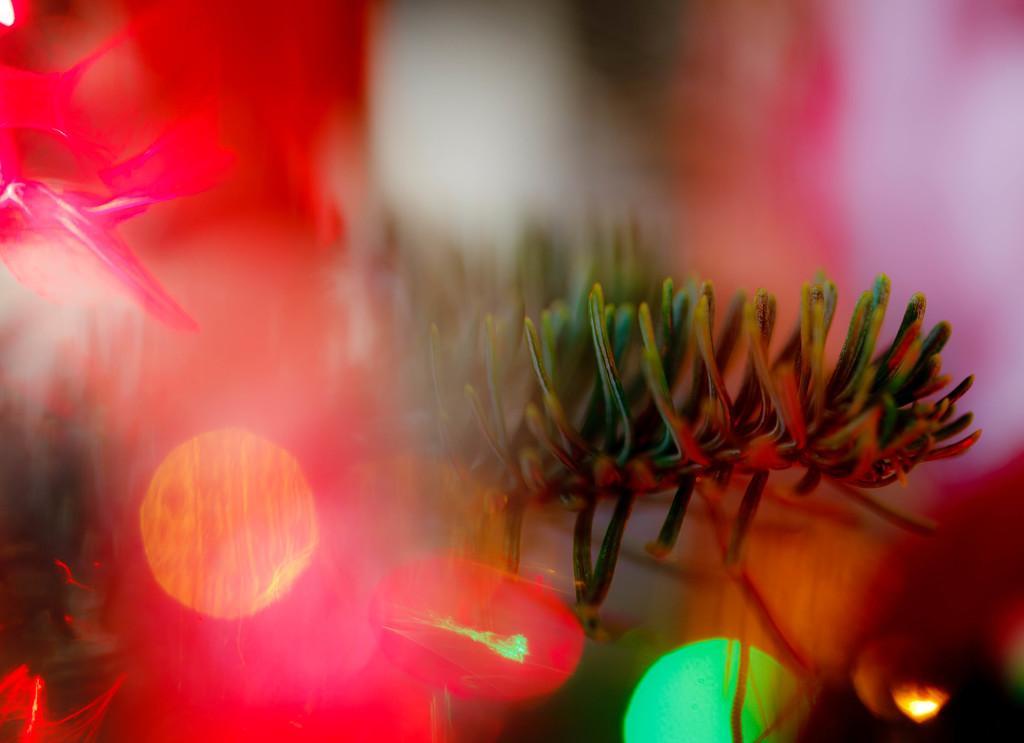In one or two sentences, can you explain what this image depicts? In this picture we can see few lights and blurry background. 